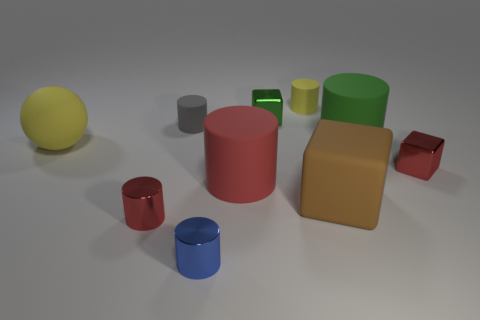Subtract all yellow cylinders. How many cylinders are left? 5 Subtract all large green rubber cylinders. How many cylinders are left? 5 Subtract 2 cylinders. How many cylinders are left? 4 Subtract all gray cylinders. Subtract all cyan spheres. How many cylinders are left? 5 Subtract all blocks. How many objects are left? 7 Add 6 rubber cubes. How many rubber cubes are left? 7 Add 7 yellow matte things. How many yellow matte things exist? 9 Subtract 2 red cylinders. How many objects are left? 8 Subtract all small green objects. Subtract all green rubber objects. How many objects are left? 8 